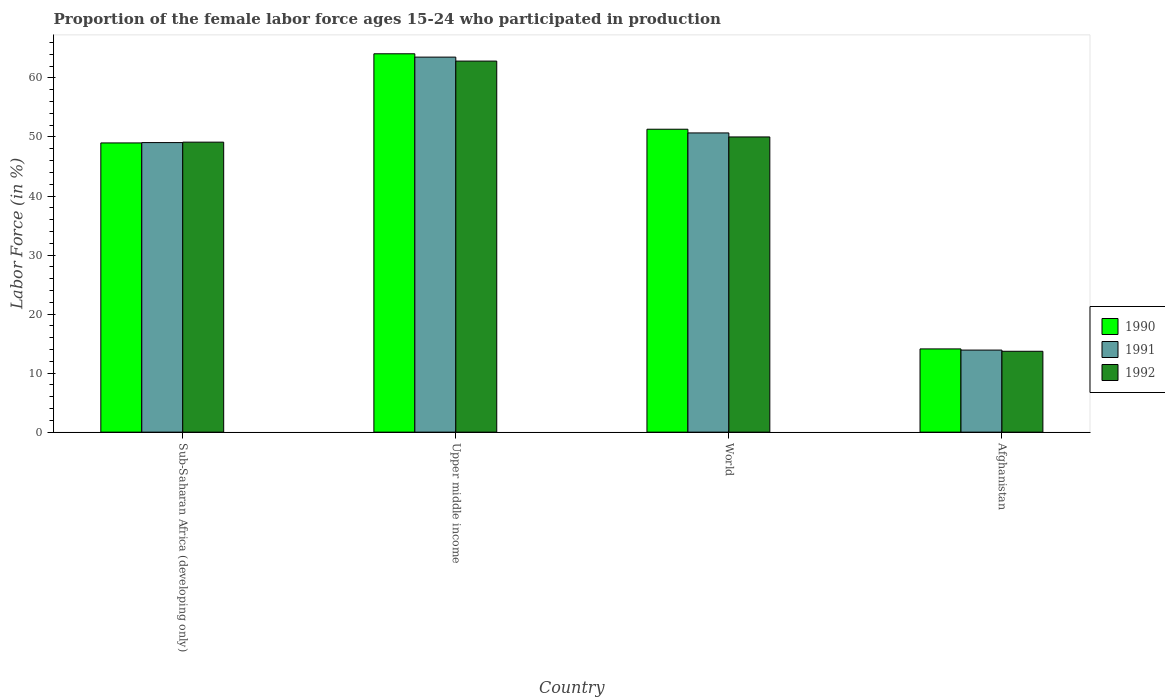How many different coloured bars are there?
Your response must be concise. 3. Are the number of bars on each tick of the X-axis equal?
Offer a very short reply. Yes. How many bars are there on the 4th tick from the right?
Your response must be concise. 3. What is the label of the 1st group of bars from the left?
Offer a very short reply. Sub-Saharan Africa (developing only). In how many cases, is the number of bars for a given country not equal to the number of legend labels?
Keep it short and to the point. 0. What is the proportion of the female labor force who participated in production in 1990 in Sub-Saharan Africa (developing only)?
Ensure brevity in your answer.  48.99. Across all countries, what is the maximum proportion of the female labor force who participated in production in 1990?
Keep it short and to the point. 64.09. Across all countries, what is the minimum proportion of the female labor force who participated in production in 1990?
Offer a very short reply. 14.1. In which country was the proportion of the female labor force who participated in production in 1991 maximum?
Your answer should be very brief. Upper middle income. In which country was the proportion of the female labor force who participated in production in 1992 minimum?
Your answer should be compact. Afghanistan. What is the total proportion of the female labor force who participated in production in 1992 in the graph?
Offer a terse response. 175.68. What is the difference between the proportion of the female labor force who participated in production in 1991 in Sub-Saharan Africa (developing only) and that in World?
Ensure brevity in your answer.  -1.64. What is the difference between the proportion of the female labor force who participated in production in 1991 in World and the proportion of the female labor force who participated in production in 1992 in Sub-Saharan Africa (developing only)?
Provide a succinct answer. 1.56. What is the average proportion of the female labor force who participated in production in 1990 per country?
Ensure brevity in your answer.  44.62. What is the difference between the proportion of the female labor force who participated in production of/in 1990 and proportion of the female labor force who participated in production of/in 1992 in Upper middle income?
Offer a terse response. 1.24. What is the ratio of the proportion of the female labor force who participated in production in 1991 in Afghanistan to that in Upper middle income?
Your answer should be compact. 0.22. Is the proportion of the female labor force who participated in production in 1992 in Sub-Saharan Africa (developing only) less than that in World?
Keep it short and to the point. Yes. What is the difference between the highest and the second highest proportion of the female labor force who participated in production in 1991?
Offer a terse response. -1.64. What is the difference between the highest and the lowest proportion of the female labor force who participated in production in 1990?
Provide a succinct answer. 49.99. In how many countries, is the proportion of the female labor force who participated in production in 1992 greater than the average proportion of the female labor force who participated in production in 1992 taken over all countries?
Ensure brevity in your answer.  3. What does the 3rd bar from the left in Afghanistan represents?
Provide a short and direct response. 1992. What does the 1st bar from the right in Upper middle income represents?
Provide a short and direct response. 1992. Is it the case that in every country, the sum of the proportion of the female labor force who participated in production in 1991 and proportion of the female labor force who participated in production in 1990 is greater than the proportion of the female labor force who participated in production in 1992?
Offer a very short reply. Yes. Are the values on the major ticks of Y-axis written in scientific E-notation?
Your response must be concise. No. Does the graph contain any zero values?
Offer a terse response. No. How many legend labels are there?
Keep it short and to the point. 3. What is the title of the graph?
Keep it short and to the point. Proportion of the female labor force ages 15-24 who participated in production. Does "1981" appear as one of the legend labels in the graph?
Provide a short and direct response. No. What is the Labor Force (in %) in 1990 in Sub-Saharan Africa (developing only)?
Provide a succinct answer. 48.99. What is the Labor Force (in %) of 1991 in Sub-Saharan Africa (developing only)?
Your response must be concise. 49.05. What is the Labor Force (in %) of 1992 in Sub-Saharan Africa (developing only)?
Give a very brief answer. 49.12. What is the Labor Force (in %) of 1990 in Upper middle income?
Your answer should be compact. 64.09. What is the Labor Force (in %) in 1991 in Upper middle income?
Provide a succinct answer. 63.53. What is the Labor Force (in %) in 1992 in Upper middle income?
Your answer should be compact. 62.85. What is the Labor Force (in %) of 1990 in World?
Give a very brief answer. 51.31. What is the Labor Force (in %) of 1991 in World?
Make the answer very short. 50.69. What is the Labor Force (in %) in 1992 in World?
Your answer should be compact. 50.01. What is the Labor Force (in %) of 1990 in Afghanistan?
Your response must be concise. 14.1. What is the Labor Force (in %) in 1991 in Afghanistan?
Your response must be concise. 13.9. What is the Labor Force (in %) in 1992 in Afghanistan?
Provide a succinct answer. 13.7. Across all countries, what is the maximum Labor Force (in %) in 1990?
Offer a terse response. 64.09. Across all countries, what is the maximum Labor Force (in %) of 1991?
Ensure brevity in your answer.  63.53. Across all countries, what is the maximum Labor Force (in %) in 1992?
Your answer should be very brief. 62.85. Across all countries, what is the minimum Labor Force (in %) in 1990?
Offer a very short reply. 14.1. Across all countries, what is the minimum Labor Force (in %) in 1991?
Offer a very short reply. 13.9. Across all countries, what is the minimum Labor Force (in %) of 1992?
Offer a terse response. 13.7. What is the total Labor Force (in %) of 1990 in the graph?
Keep it short and to the point. 178.49. What is the total Labor Force (in %) of 1991 in the graph?
Keep it short and to the point. 177.16. What is the total Labor Force (in %) of 1992 in the graph?
Keep it short and to the point. 175.68. What is the difference between the Labor Force (in %) of 1990 in Sub-Saharan Africa (developing only) and that in Upper middle income?
Ensure brevity in your answer.  -15.1. What is the difference between the Labor Force (in %) in 1991 in Sub-Saharan Africa (developing only) and that in Upper middle income?
Your response must be concise. -14.48. What is the difference between the Labor Force (in %) in 1992 in Sub-Saharan Africa (developing only) and that in Upper middle income?
Ensure brevity in your answer.  -13.73. What is the difference between the Labor Force (in %) in 1990 in Sub-Saharan Africa (developing only) and that in World?
Make the answer very short. -2.32. What is the difference between the Labor Force (in %) in 1991 in Sub-Saharan Africa (developing only) and that in World?
Offer a very short reply. -1.64. What is the difference between the Labor Force (in %) of 1992 in Sub-Saharan Africa (developing only) and that in World?
Ensure brevity in your answer.  -0.88. What is the difference between the Labor Force (in %) of 1990 in Sub-Saharan Africa (developing only) and that in Afghanistan?
Offer a very short reply. 34.89. What is the difference between the Labor Force (in %) of 1991 in Sub-Saharan Africa (developing only) and that in Afghanistan?
Make the answer very short. 35.15. What is the difference between the Labor Force (in %) in 1992 in Sub-Saharan Africa (developing only) and that in Afghanistan?
Offer a very short reply. 35.42. What is the difference between the Labor Force (in %) in 1990 in Upper middle income and that in World?
Offer a terse response. 12.78. What is the difference between the Labor Force (in %) in 1991 in Upper middle income and that in World?
Ensure brevity in your answer.  12.84. What is the difference between the Labor Force (in %) of 1992 in Upper middle income and that in World?
Offer a terse response. 12.85. What is the difference between the Labor Force (in %) in 1990 in Upper middle income and that in Afghanistan?
Ensure brevity in your answer.  49.99. What is the difference between the Labor Force (in %) of 1991 in Upper middle income and that in Afghanistan?
Your answer should be compact. 49.63. What is the difference between the Labor Force (in %) in 1992 in Upper middle income and that in Afghanistan?
Your response must be concise. 49.15. What is the difference between the Labor Force (in %) in 1990 in World and that in Afghanistan?
Make the answer very short. 37.21. What is the difference between the Labor Force (in %) in 1991 in World and that in Afghanistan?
Your answer should be compact. 36.79. What is the difference between the Labor Force (in %) in 1992 in World and that in Afghanistan?
Give a very brief answer. 36.31. What is the difference between the Labor Force (in %) in 1990 in Sub-Saharan Africa (developing only) and the Labor Force (in %) in 1991 in Upper middle income?
Your answer should be compact. -14.54. What is the difference between the Labor Force (in %) in 1990 in Sub-Saharan Africa (developing only) and the Labor Force (in %) in 1992 in Upper middle income?
Your answer should be very brief. -13.86. What is the difference between the Labor Force (in %) of 1991 in Sub-Saharan Africa (developing only) and the Labor Force (in %) of 1992 in Upper middle income?
Your answer should be very brief. -13.81. What is the difference between the Labor Force (in %) of 1990 in Sub-Saharan Africa (developing only) and the Labor Force (in %) of 1991 in World?
Your answer should be very brief. -1.69. What is the difference between the Labor Force (in %) of 1990 in Sub-Saharan Africa (developing only) and the Labor Force (in %) of 1992 in World?
Ensure brevity in your answer.  -1.01. What is the difference between the Labor Force (in %) in 1991 in Sub-Saharan Africa (developing only) and the Labor Force (in %) in 1992 in World?
Keep it short and to the point. -0.96. What is the difference between the Labor Force (in %) of 1990 in Sub-Saharan Africa (developing only) and the Labor Force (in %) of 1991 in Afghanistan?
Provide a succinct answer. 35.09. What is the difference between the Labor Force (in %) of 1990 in Sub-Saharan Africa (developing only) and the Labor Force (in %) of 1992 in Afghanistan?
Give a very brief answer. 35.29. What is the difference between the Labor Force (in %) in 1991 in Sub-Saharan Africa (developing only) and the Labor Force (in %) in 1992 in Afghanistan?
Keep it short and to the point. 35.35. What is the difference between the Labor Force (in %) in 1990 in Upper middle income and the Labor Force (in %) in 1991 in World?
Ensure brevity in your answer.  13.4. What is the difference between the Labor Force (in %) in 1990 in Upper middle income and the Labor Force (in %) in 1992 in World?
Your response must be concise. 14.08. What is the difference between the Labor Force (in %) in 1991 in Upper middle income and the Labor Force (in %) in 1992 in World?
Provide a short and direct response. 13.52. What is the difference between the Labor Force (in %) in 1990 in Upper middle income and the Labor Force (in %) in 1991 in Afghanistan?
Give a very brief answer. 50.19. What is the difference between the Labor Force (in %) of 1990 in Upper middle income and the Labor Force (in %) of 1992 in Afghanistan?
Your answer should be very brief. 50.39. What is the difference between the Labor Force (in %) in 1991 in Upper middle income and the Labor Force (in %) in 1992 in Afghanistan?
Your response must be concise. 49.83. What is the difference between the Labor Force (in %) of 1990 in World and the Labor Force (in %) of 1991 in Afghanistan?
Your response must be concise. 37.41. What is the difference between the Labor Force (in %) in 1990 in World and the Labor Force (in %) in 1992 in Afghanistan?
Your answer should be compact. 37.61. What is the difference between the Labor Force (in %) of 1991 in World and the Labor Force (in %) of 1992 in Afghanistan?
Make the answer very short. 36.99. What is the average Labor Force (in %) of 1990 per country?
Provide a succinct answer. 44.62. What is the average Labor Force (in %) in 1991 per country?
Ensure brevity in your answer.  44.29. What is the average Labor Force (in %) in 1992 per country?
Offer a very short reply. 43.92. What is the difference between the Labor Force (in %) in 1990 and Labor Force (in %) in 1991 in Sub-Saharan Africa (developing only)?
Your response must be concise. -0.06. What is the difference between the Labor Force (in %) of 1990 and Labor Force (in %) of 1992 in Sub-Saharan Africa (developing only)?
Provide a succinct answer. -0.13. What is the difference between the Labor Force (in %) of 1991 and Labor Force (in %) of 1992 in Sub-Saharan Africa (developing only)?
Keep it short and to the point. -0.07. What is the difference between the Labor Force (in %) in 1990 and Labor Force (in %) in 1991 in Upper middle income?
Give a very brief answer. 0.56. What is the difference between the Labor Force (in %) of 1990 and Labor Force (in %) of 1992 in Upper middle income?
Ensure brevity in your answer.  1.24. What is the difference between the Labor Force (in %) in 1991 and Labor Force (in %) in 1992 in Upper middle income?
Offer a terse response. 0.67. What is the difference between the Labor Force (in %) in 1990 and Labor Force (in %) in 1991 in World?
Your answer should be compact. 0.63. What is the difference between the Labor Force (in %) of 1990 and Labor Force (in %) of 1992 in World?
Offer a terse response. 1.31. What is the difference between the Labor Force (in %) in 1991 and Labor Force (in %) in 1992 in World?
Your answer should be very brief. 0.68. What is the difference between the Labor Force (in %) in 1990 and Labor Force (in %) in 1992 in Afghanistan?
Your answer should be very brief. 0.4. What is the ratio of the Labor Force (in %) of 1990 in Sub-Saharan Africa (developing only) to that in Upper middle income?
Your response must be concise. 0.76. What is the ratio of the Labor Force (in %) of 1991 in Sub-Saharan Africa (developing only) to that in Upper middle income?
Your answer should be compact. 0.77. What is the ratio of the Labor Force (in %) of 1992 in Sub-Saharan Africa (developing only) to that in Upper middle income?
Provide a succinct answer. 0.78. What is the ratio of the Labor Force (in %) in 1990 in Sub-Saharan Africa (developing only) to that in World?
Your response must be concise. 0.95. What is the ratio of the Labor Force (in %) of 1991 in Sub-Saharan Africa (developing only) to that in World?
Ensure brevity in your answer.  0.97. What is the ratio of the Labor Force (in %) of 1992 in Sub-Saharan Africa (developing only) to that in World?
Offer a terse response. 0.98. What is the ratio of the Labor Force (in %) of 1990 in Sub-Saharan Africa (developing only) to that in Afghanistan?
Keep it short and to the point. 3.47. What is the ratio of the Labor Force (in %) of 1991 in Sub-Saharan Africa (developing only) to that in Afghanistan?
Your answer should be very brief. 3.53. What is the ratio of the Labor Force (in %) in 1992 in Sub-Saharan Africa (developing only) to that in Afghanistan?
Provide a short and direct response. 3.59. What is the ratio of the Labor Force (in %) in 1990 in Upper middle income to that in World?
Give a very brief answer. 1.25. What is the ratio of the Labor Force (in %) of 1991 in Upper middle income to that in World?
Provide a short and direct response. 1.25. What is the ratio of the Labor Force (in %) of 1992 in Upper middle income to that in World?
Give a very brief answer. 1.26. What is the ratio of the Labor Force (in %) in 1990 in Upper middle income to that in Afghanistan?
Give a very brief answer. 4.55. What is the ratio of the Labor Force (in %) in 1991 in Upper middle income to that in Afghanistan?
Provide a succinct answer. 4.57. What is the ratio of the Labor Force (in %) in 1992 in Upper middle income to that in Afghanistan?
Your answer should be compact. 4.59. What is the ratio of the Labor Force (in %) of 1990 in World to that in Afghanistan?
Offer a terse response. 3.64. What is the ratio of the Labor Force (in %) of 1991 in World to that in Afghanistan?
Your response must be concise. 3.65. What is the ratio of the Labor Force (in %) in 1992 in World to that in Afghanistan?
Your response must be concise. 3.65. What is the difference between the highest and the second highest Labor Force (in %) in 1990?
Give a very brief answer. 12.78. What is the difference between the highest and the second highest Labor Force (in %) of 1991?
Offer a very short reply. 12.84. What is the difference between the highest and the second highest Labor Force (in %) of 1992?
Your response must be concise. 12.85. What is the difference between the highest and the lowest Labor Force (in %) of 1990?
Provide a succinct answer. 49.99. What is the difference between the highest and the lowest Labor Force (in %) in 1991?
Your answer should be compact. 49.63. What is the difference between the highest and the lowest Labor Force (in %) of 1992?
Your answer should be compact. 49.15. 